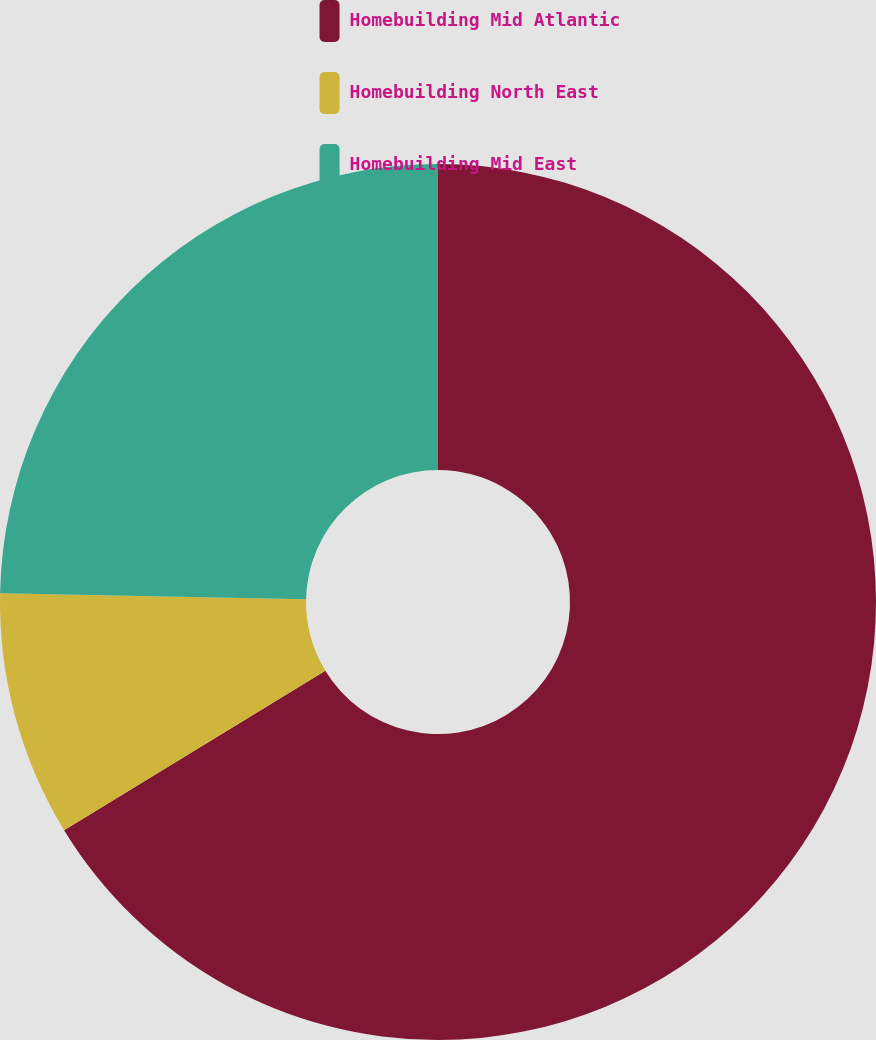<chart> <loc_0><loc_0><loc_500><loc_500><pie_chart><fcel>Homebuilding Mid Atlantic<fcel>Homebuilding North East<fcel>Homebuilding Mid East<nl><fcel>66.28%<fcel>9.04%<fcel>24.68%<nl></chart> 